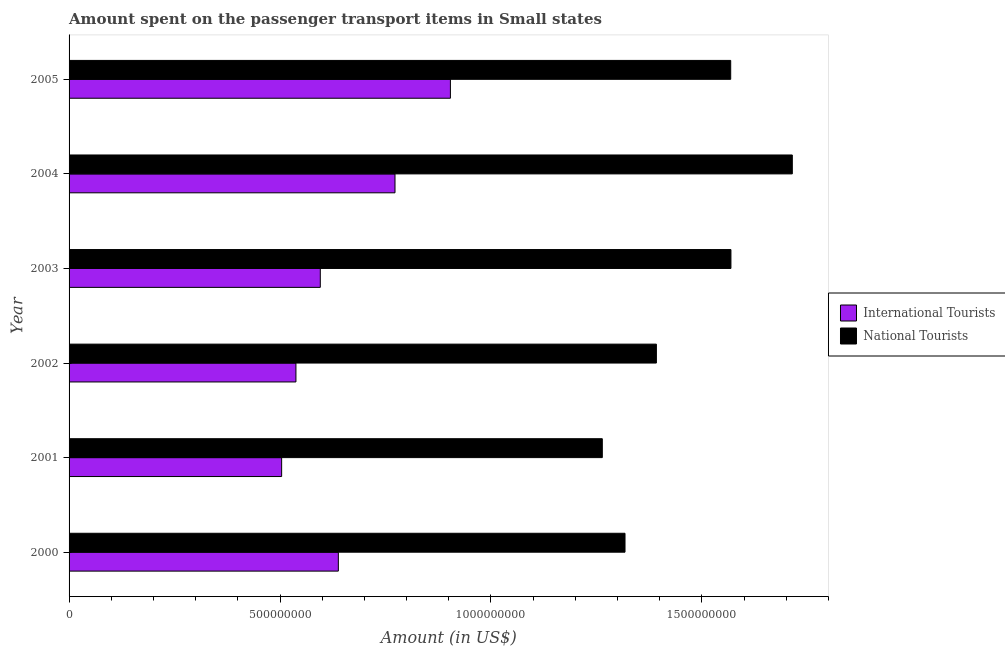Are the number of bars per tick equal to the number of legend labels?
Offer a terse response. Yes. Are the number of bars on each tick of the Y-axis equal?
Keep it short and to the point. Yes. What is the label of the 1st group of bars from the top?
Keep it short and to the point. 2005. What is the amount spent on transport items of international tourists in 2005?
Provide a short and direct response. 9.04e+08. Across all years, what is the maximum amount spent on transport items of international tourists?
Your answer should be compact. 9.04e+08. Across all years, what is the minimum amount spent on transport items of national tourists?
Provide a succinct answer. 1.26e+09. In which year was the amount spent on transport items of national tourists maximum?
Provide a short and direct response. 2004. What is the total amount spent on transport items of international tourists in the graph?
Your answer should be compact. 3.95e+09. What is the difference between the amount spent on transport items of international tourists in 2003 and that in 2004?
Keep it short and to the point. -1.77e+08. What is the difference between the amount spent on transport items of international tourists in 2004 and the amount spent on transport items of national tourists in 2001?
Provide a short and direct response. -4.91e+08. What is the average amount spent on transport items of national tourists per year?
Provide a succinct answer. 1.47e+09. In the year 2002, what is the difference between the amount spent on transport items of national tourists and amount spent on transport items of international tourists?
Your answer should be compact. 8.54e+08. What is the ratio of the amount spent on transport items of national tourists in 2000 to that in 2003?
Provide a succinct answer. 0.84. What is the difference between the highest and the second highest amount spent on transport items of international tourists?
Provide a short and direct response. 1.31e+08. What is the difference between the highest and the lowest amount spent on transport items of national tourists?
Provide a succinct answer. 4.50e+08. In how many years, is the amount spent on transport items of national tourists greater than the average amount spent on transport items of national tourists taken over all years?
Offer a very short reply. 3. What does the 1st bar from the top in 2000 represents?
Give a very brief answer. National Tourists. What does the 2nd bar from the bottom in 2003 represents?
Provide a short and direct response. National Tourists. How many bars are there?
Your answer should be compact. 12. How many years are there in the graph?
Offer a very short reply. 6. Does the graph contain any zero values?
Your answer should be compact. No. Does the graph contain grids?
Your answer should be compact. No. How many legend labels are there?
Provide a succinct answer. 2. How are the legend labels stacked?
Give a very brief answer. Vertical. What is the title of the graph?
Keep it short and to the point. Amount spent on the passenger transport items in Small states. What is the Amount (in US$) in International Tourists in 2000?
Offer a terse response. 6.38e+08. What is the Amount (in US$) of National Tourists in 2000?
Offer a terse response. 1.32e+09. What is the Amount (in US$) of International Tourists in 2001?
Your response must be concise. 5.04e+08. What is the Amount (in US$) in National Tourists in 2001?
Offer a very short reply. 1.26e+09. What is the Amount (in US$) of International Tourists in 2002?
Offer a very short reply. 5.38e+08. What is the Amount (in US$) in National Tourists in 2002?
Your answer should be very brief. 1.39e+09. What is the Amount (in US$) of International Tourists in 2003?
Your response must be concise. 5.95e+08. What is the Amount (in US$) in National Tourists in 2003?
Provide a succinct answer. 1.57e+09. What is the Amount (in US$) in International Tourists in 2004?
Your response must be concise. 7.73e+08. What is the Amount (in US$) in National Tourists in 2004?
Ensure brevity in your answer.  1.71e+09. What is the Amount (in US$) in International Tourists in 2005?
Your answer should be compact. 9.04e+08. What is the Amount (in US$) in National Tourists in 2005?
Your answer should be compact. 1.57e+09. Across all years, what is the maximum Amount (in US$) of International Tourists?
Provide a succinct answer. 9.04e+08. Across all years, what is the maximum Amount (in US$) of National Tourists?
Give a very brief answer. 1.71e+09. Across all years, what is the minimum Amount (in US$) in International Tourists?
Offer a terse response. 5.04e+08. Across all years, what is the minimum Amount (in US$) of National Tourists?
Your response must be concise. 1.26e+09. What is the total Amount (in US$) in International Tourists in the graph?
Your answer should be very brief. 3.95e+09. What is the total Amount (in US$) in National Tourists in the graph?
Your response must be concise. 8.83e+09. What is the difference between the Amount (in US$) of International Tourists in 2000 and that in 2001?
Offer a very short reply. 1.34e+08. What is the difference between the Amount (in US$) in National Tourists in 2000 and that in 2001?
Your answer should be compact. 5.38e+07. What is the difference between the Amount (in US$) of International Tourists in 2000 and that in 2002?
Provide a short and direct response. 1.01e+08. What is the difference between the Amount (in US$) of National Tourists in 2000 and that in 2002?
Your response must be concise. -7.44e+07. What is the difference between the Amount (in US$) of International Tourists in 2000 and that in 2003?
Make the answer very short. 4.28e+07. What is the difference between the Amount (in US$) of National Tourists in 2000 and that in 2003?
Your answer should be compact. -2.51e+08. What is the difference between the Amount (in US$) in International Tourists in 2000 and that in 2004?
Make the answer very short. -1.34e+08. What is the difference between the Amount (in US$) in National Tourists in 2000 and that in 2004?
Give a very brief answer. -3.97e+08. What is the difference between the Amount (in US$) of International Tourists in 2000 and that in 2005?
Offer a very short reply. -2.66e+08. What is the difference between the Amount (in US$) of National Tourists in 2000 and that in 2005?
Offer a terse response. -2.51e+08. What is the difference between the Amount (in US$) of International Tourists in 2001 and that in 2002?
Offer a very short reply. -3.39e+07. What is the difference between the Amount (in US$) in National Tourists in 2001 and that in 2002?
Your answer should be compact. -1.28e+08. What is the difference between the Amount (in US$) in International Tourists in 2001 and that in 2003?
Keep it short and to the point. -9.16e+07. What is the difference between the Amount (in US$) in National Tourists in 2001 and that in 2003?
Provide a succinct answer. -3.05e+08. What is the difference between the Amount (in US$) in International Tourists in 2001 and that in 2004?
Your answer should be compact. -2.69e+08. What is the difference between the Amount (in US$) in National Tourists in 2001 and that in 2004?
Ensure brevity in your answer.  -4.50e+08. What is the difference between the Amount (in US$) in International Tourists in 2001 and that in 2005?
Ensure brevity in your answer.  -4.00e+08. What is the difference between the Amount (in US$) in National Tourists in 2001 and that in 2005?
Make the answer very short. -3.04e+08. What is the difference between the Amount (in US$) of International Tourists in 2002 and that in 2003?
Offer a terse response. -5.77e+07. What is the difference between the Amount (in US$) in National Tourists in 2002 and that in 2003?
Offer a terse response. -1.77e+08. What is the difference between the Amount (in US$) of International Tourists in 2002 and that in 2004?
Keep it short and to the point. -2.35e+08. What is the difference between the Amount (in US$) in National Tourists in 2002 and that in 2004?
Ensure brevity in your answer.  -3.22e+08. What is the difference between the Amount (in US$) in International Tourists in 2002 and that in 2005?
Your response must be concise. -3.66e+08. What is the difference between the Amount (in US$) in National Tourists in 2002 and that in 2005?
Your response must be concise. -1.76e+08. What is the difference between the Amount (in US$) in International Tourists in 2003 and that in 2004?
Your answer should be very brief. -1.77e+08. What is the difference between the Amount (in US$) of National Tourists in 2003 and that in 2004?
Offer a terse response. -1.45e+08. What is the difference between the Amount (in US$) in International Tourists in 2003 and that in 2005?
Your answer should be very brief. -3.08e+08. What is the difference between the Amount (in US$) in National Tourists in 2003 and that in 2005?
Your response must be concise. 5.74e+05. What is the difference between the Amount (in US$) in International Tourists in 2004 and that in 2005?
Make the answer very short. -1.31e+08. What is the difference between the Amount (in US$) of National Tourists in 2004 and that in 2005?
Your answer should be compact. 1.46e+08. What is the difference between the Amount (in US$) of International Tourists in 2000 and the Amount (in US$) of National Tourists in 2001?
Your answer should be compact. -6.26e+08. What is the difference between the Amount (in US$) of International Tourists in 2000 and the Amount (in US$) of National Tourists in 2002?
Provide a succinct answer. -7.54e+08. What is the difference between the Amount (in US$) in International Tourists in 2000 and the Amount (in US$) in National Tourists in 2003?
Make the answer very short. -9.31e+08. What is the difference between the Amount (in US$) of International Tourists in 2000 and the Amount (in US$) of National Tourists in 2004?
Your answer should be compact. -1.08e+09. What is the difference between the Amount (in US$) in International Tourists in 2000 and the Amount (in US$) in National Tourists in 2005?
Make the answer very short. -9.30e+08. What is the difference between the Amount (in US$) in International Tourists in 2001 and the Amount (in US$) in National Tourists in 2002?
Ensure brevity in your answer.  -8.88e+08. What is the difference between the Amount (in US$) of International Tourists in 2001 and the Amount (in US$) of National Tourists in 2003?
Make the answer very short. -1.06e+09. What is the difference between the Amount (in US$) in International Tourists in 2001 and the Amount (in US$) in National Tourists in 2004?
Your response must be concise. -1.21e+09. What is the difference between the Amount (in US$) in International Tourists in 2001 and the Amount (in US$) in National Tourists in 2005?
Provide a succinct answer. -1.06e+09. What is the difference between the Amount (in US$) of International Tourists in 2002 and the Amount (in US$) of National Tourists in 2003?
Provide a succinct answer. -1.03e+09. What is the difference between the Amount (in US$) in International Tourists in 2002 and the Amount (in US$) in National Tourists in 2004?
Offer a very short reply. -1.18e+09. What is the difference between the Amount (in US$) of International Tourists in 2002 and the Amount (in US$) of National Tourists in 2005?
Provide a succinct answer. -1.03e+09. What is the difference between the Amount (in US$) in International Tourists in 2003 and the Amount (in US$) in National Tourists in 2004?
Provide a short and direct response. -1.12e+09. What is the difference between the Amount (in US$) in International Tourists in 2003 and the Amount (in US$) in National Tourists in 2005?
Provide a short and direct response. -9.73e+08. What is the difference between the Amount (in US$) in International Tourists in 2004 and the Amount (in US$) in National Tourists in 2005?
Provide a short and direct response. -7.96e+08. What is the average Amount (in US$) of International Tourists per year?
Your answer should be compact. 6.59e+08. What is the average Amount (in US$) in National Tourists per year?
Make the answer very short. 1.47e+09. In the year 2000, what is the difference between the Amount (in US$) of International Tourists and Amount (in US$) of National Tourists?
Give a very brief answer. -6.80e+08. In the year 2001, what is the difference between the Amount (in US$) in International Tourists and Amount (in US$) in National Tourists?
Keep it short and to the point. -7.60e+08. In the year 2002, what is the difference between the Amount (in US$) of International Tourists and Amount (in US$) of National Tourists?
Ensure brevity in your answer.  -8.54e+08. In the year 2003, what is the difference between the Amount (in US$) of International Tourists and Amount (in US$) of National Tourists?
Ensure brevity in your answer.  -9.73e+08. In the year 2004, what is the difference between the Amount (in US$) of International Tourists and Amount (in US$) of National Tourists?
Offer a terse response. -9.42e+08. In the year 2005, what is the difference between the Amount (in US$) of International Tourists and Amount (in US$) of National Tourists?
Offer a very short reply. -6.64e+08. What is the ratio of the Amount (in US$) in International Tourists in 2000 to that in 2001?
Offer a very short reply. 1.27. What is the ratio of the Amount (in US$) of National Tourists in 2000 to that in 2001?
Your answer should be very brief. 1.04. What is the ratio of the Amount (in US$) in International Tourists in 2000 to that in 2002?
Provide a short and direct response. 1.19. What is the ratio of the Amount (in US$) in National Tourists in 2000 to that in 2002?
Provide a succinct answer. 0.95. What is the ratio of the Amount (in US$) of International Tourists in 2000 to that in 2003?
Give a very brief answer. 1.07. What is the ratio of the Amount (in US$) of National Tourists in 2000 to that in 2003?
Your response must be concise. 0.84. What is the ratio of the Amount (in US$) of International Tourists in 2000 to that in 2004?
Offer a terse response. 0.83. What is the ratio of the Amount (in US$) of National Tourists in 2000 to that in 2004?
Your response must be concise. 0.77. What is the ratio of the Amount (in US$) of International Tourists in 2000 to that in 2005?
Offer a terse response. 0.71. What is the ratio of the Amount (in US$) of National Tourists in 2000 to that in 2005?
Offer a terse response. 0.84. What is the ratio of the Amount (in US$) in International Tourists in 2001 to that in 2002?
Ensure brevity in your answer.  0.94. What is the ratio of the Amount (in US$) of National Tourists in 2001 to that in 2002?
Ensure brevity in your answer.  0.91. What is the ratio of the Amount (in US$) in International Tourists in 2001 to that in 2003?
Your answer should be compact. 0.85. What is the ratio of the Amount (in US$) of National Tourists in 2001 to that in 2003?
Provide a short and direct response. 0.81. What is the ratio of the Amount (in US$) in International Tourists in 2001 to that in 2004?
Provide a succinct answer. 0.65. What is the ratio of the Amount (in US$) of National Tourists in 2001 to that in 2004?
Offer a terse response. 0.74. What is the ratio of the Amount (in US$) in International Tourists in 2001 to that in 2005?
Provide a short and direct response. 0.56. What is the ratio of the Amount (in US$) in National Tourists in 2001 to that in 2005?
Your answer should be compact. 0.81. What is the ratio of the Amount (in US$) of International Tourists in 2002 to that in 2003?
Ensure brevity in your answer.  0.9. What is the ratio of the Amount (in US$) in National Tourists in 2002 to that in 2003?
Provide a short and direct response. 0.89. What is the ratio of the Amount (in US$) in International Tourists in 2002 to that in 2004?
Keep it short and to the point. 0.7. What is the ratio of the Amount (in US$) in National Tourists in 2002 to that in 2004?
Offer a very short reply. 0.81. What is the ratio of the Amount (in US$) of International Tourists in 2002 to that in 2005?
Provide a succinct answer. 0.59. What is the ratio of the Amount (in US$) of National Tourists in 2002 to that in 2005?
Give a very brief answer. 0.89. What is the ratio of the Amount (in US$) in International Tourists in 2003 to that in 2004?
Provide a succinct answer. 0.77. What is the ratio of the Amount (in US$) in National Tourists in 2003 to that in 2004?
Provide a succinct answer. 0.92. What is the ratio of the Amount (in US$) of International Tourists in 2003 to that in 2005?
Provide a short and direct response. 0.66. What is the ratio of the Amount (in US$) in International Tourists in 2004 to that in 2005?
Your answer should be very brief. 0.85. What is the ratio of the Amount (in US$) in National Tourists in 2004 to that in 2005?
Your answer should be compact. 1.09. What is the difference between the highest and the second highest Amount (in US$) in International Tourists?
Make the answer very short. 1.31e+08. What is the difference between the highest and the second highest Amount (in US$) of National Tourists?
Provide a succinct answer. 1.45e+08. What is the difference between the highest and the lowest Amount (in US$) in International Tourists?
Ensure brevity in your answer.  4.00e+08. What is the difference between the highest and the lowest Amount (in US$) of National Tourists?
Give a very brief answer. 4.50e+08. 